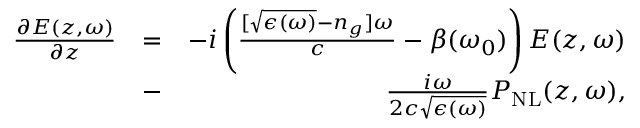Convert formula to latex. <formula><loc_0><loc_0><loc_500><loc_500>\begin{array} { r l r } { \frac { \partial E ( z , \omega ) } { \partial z } } & { = } & { - i \left ( \frac { [ \sqrt { \epsilon ( \omega ) } - n _ { g } ] \omega } { c } - \beta ( \omega _ { 0 } ) \right ) E ( z , \omega ) } \\ & { - } & { \frac { i \omega } { 2 c \sqrt { \epsilon ( \omega ) } } P _ { N L } ( z , \omega ) , } \end{array}</formula> 